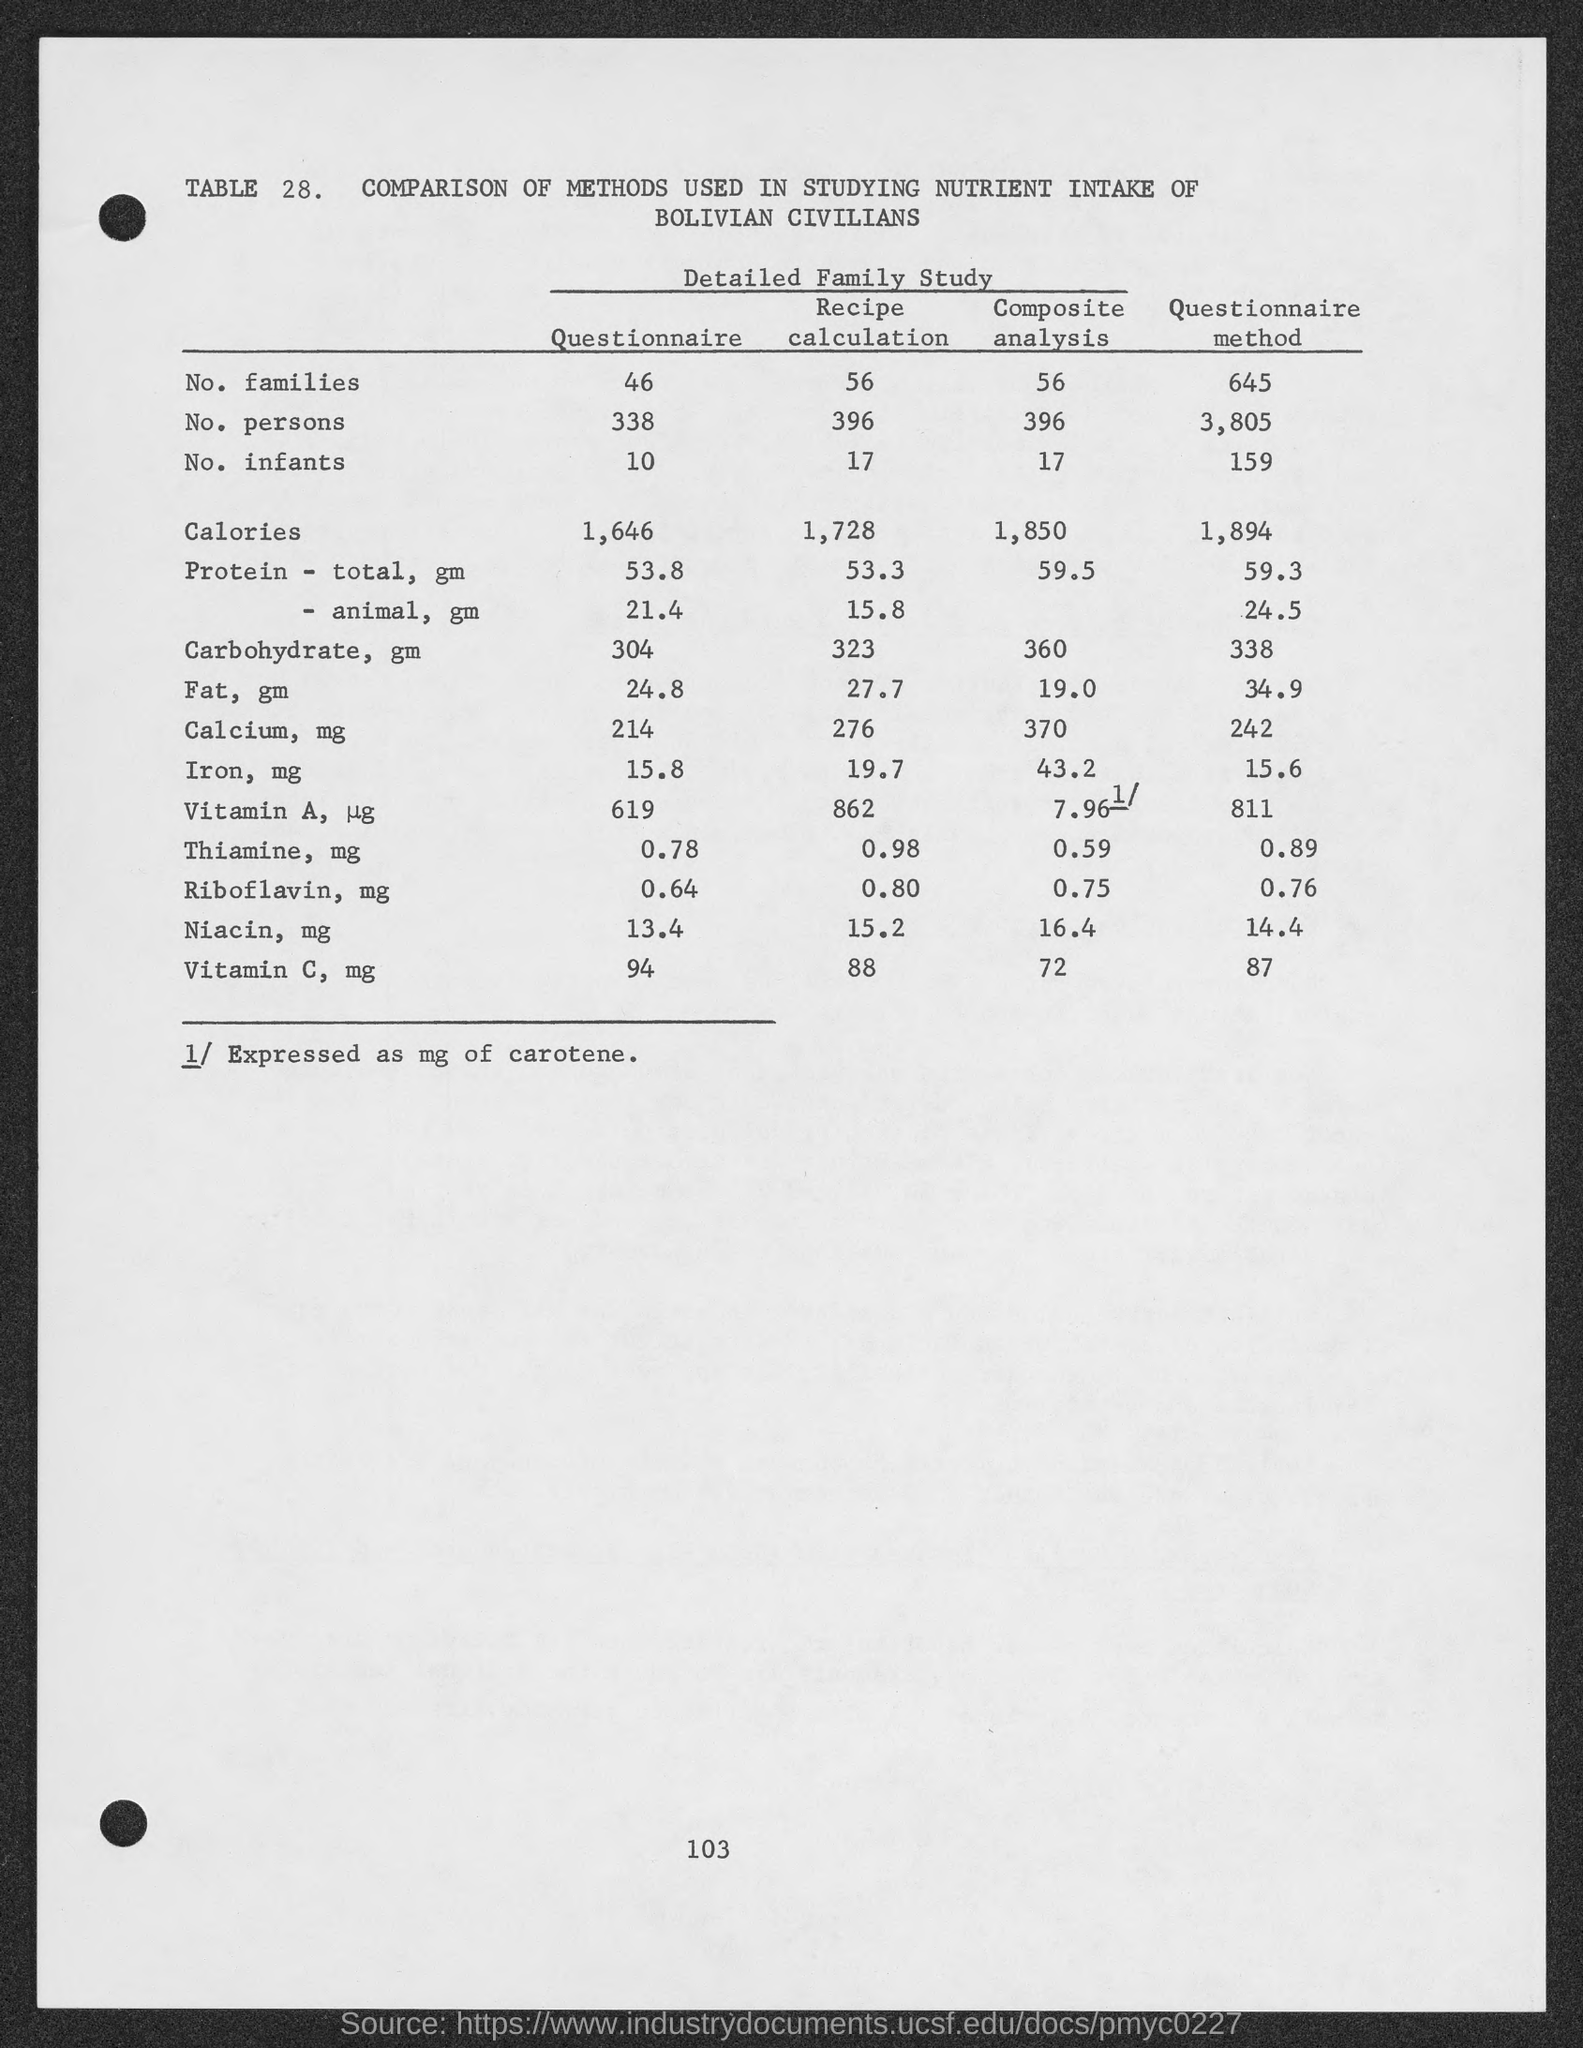What is the table number?
Keep it short and to the point. TABLE 28. What is the Page Number?
Keep it short and to the point. 103. What is the number of families in the questionnaire?
Your response must be concise. 46. What is the number of persons in the questionnaire?
Provide a short and direct response. 338. What is the number of infants in the questionnaire?
Your answer should be compact. 10. 